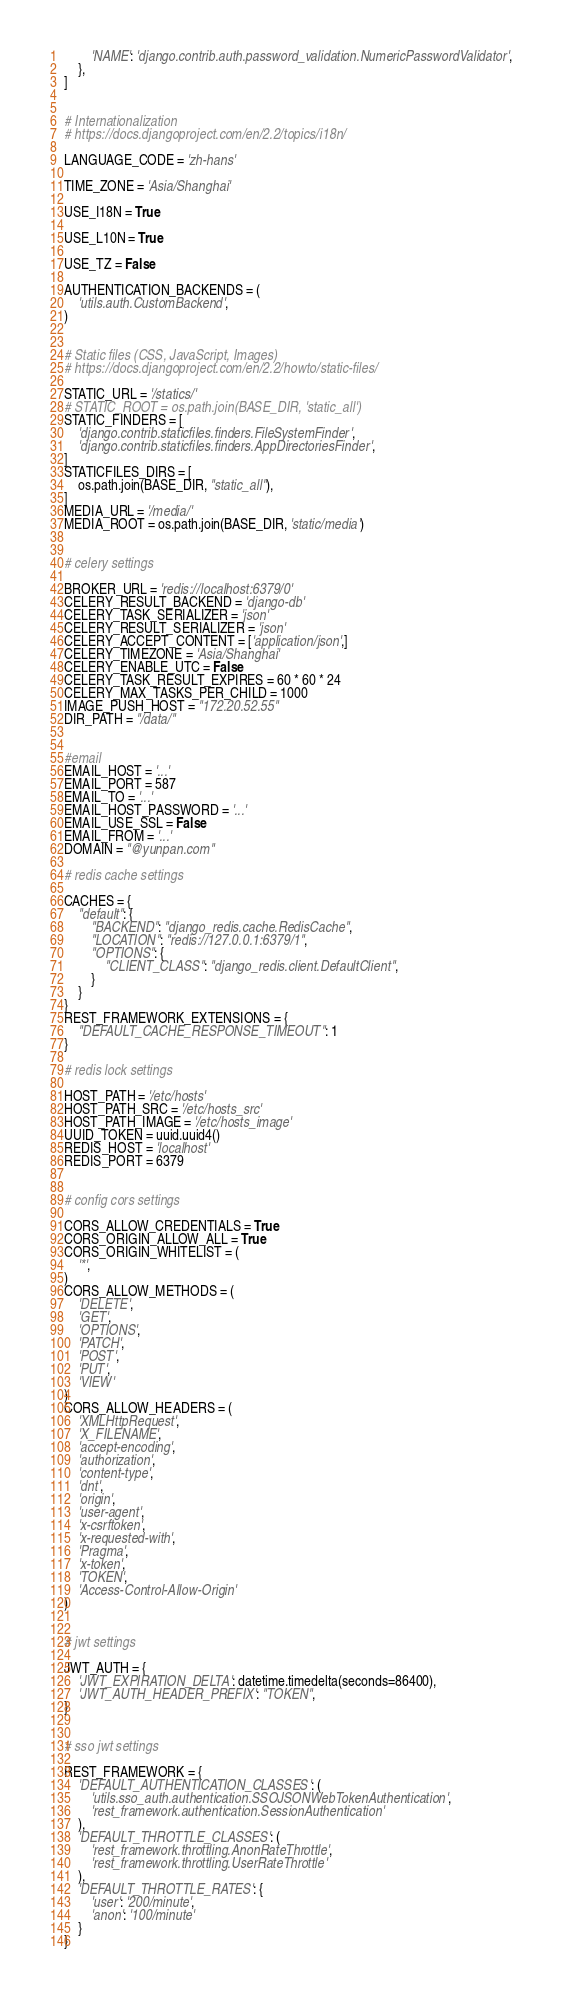<code> <loc_0><loc_0><loc_500><loc_500><_Python_>        'NAME': 'django.contrib.auth.password_validation.NumericPasswordValidator',
    },
]


# Internationalization
# https://docs.djangoproject.com/en/2.2/topics/i18n/

LANGUAGE_CODE = 'zh-hans'

TIME_ZONE = 'Asia/Shanghai'

USE_I18N = True

USE_L10N = True

USE_TZ = False

AUTHENTICATION_BACKENDS = (
    'utils.auth.CustomBackend',
)


# Static files (CSS, JavaScript, Images)
# https://docs.djangoproject.com/en/2.2/howto/static-files/

STATIC_URL = '/statics/'
# STATIC_ROOT = os.path.join(BASE_DIR, 'static_all')
STATIC_FINDERS = [
    'django.contrib.staticfiles.finders.FileSystemFinder',
    'django.contrib.staticfiles.finders.AppDirectoriesFinder',
]
STATICFILES_DIRS = [
    os.path.join(BASE_DIR, "static_all"),
]
MEDIA_URL = '/media/'
MEDIA_ROOT = os.path.join(BASE_DIR, 'static/media')


# celery settings

BROKER_URL = 'redis://localhost:6379/0'
CELERY_RESULT_BACKEND = 'django-db'
CELERY_TASK_SERIALIZER = 'json'
CELERY_RESULT_SERIALIZER = 'json'
CELERY_ACCEPT_CONTENT = ['application/json',]
CELERY_TIMEZONE = 'Asia/Shanghai'
CELERY_ENABLE_UTC = False
CELERY_TASK_RESULT_EXPIRES = 60 * 60 * 24
CELERY_MAX_TASKS_PER_CHILD = 1000
IMAGE_PUSH_HOST = "172.20.52.55"
DIR_PATH = "/data/"


#email
EMAIL_HOST = '...'
EMAIL_PORT = 587
EMAIL_TO = '...'
EMAIL_HOST_PASSWORD = '...'
EMAIL_USE_SSL = False
EMAIL_FROM = '...'
DOMAIN = "@yunpan.com"

# redis cache settings

CACHES = {
    "default": {
        "BACKEND": "django_redis.cache.RedisCache",
        "LOCATION": "redis://127.0.0.1:6379/1",
        "OPTIONS": {
            "CLIENT_CLASS": "django_redis.client.DefaultClient",
        }
    }
}
REST_FRAMEWORK_EXTENSIONS = {
    "DEFAULT_CACHE_RESPONSE_TIMEOUT": 1
}

# redis lock settings

HOST_PATH = '/etc/hosts'
HOST_PATH_SRC = '/etc/hosts_src'
HOST_PATH_IMAGE = '/etc/hosts_image'
UUID_TOKEN = uuid.uuid4()
REDIS_HOST = 'localhost'
REDIS_PORT = 6379


# config cors settings

CORS_ALLOW_CREDENTIALS = True
CORS_ORIGIN_ALLOW_ALL = True
CORS_ORIGIN_WHITELIST = (
    '*',
)
CORS_ALLOW_METHODS = (
    'DELETE',
    'GET',
    'OPTIONS',
    'PATCH',
    'POST',
    'PUT',
    'VIEW'
)
CORS_ALLOW_HEADERS = (
    'XMLHttpRequest',
    'X_FILENAME',
    'accept-encoding',
    'authorization',
    'content-type',
    'dnt',
    'origin',
    'user-agent',
    'x-csrftoken',
    'x-requested-with',
    'Pragma',
    'x-token',
    'TOKEN',
    'Access-Control-Allow-Origin'
)


# jwt settings

JWT_AUTH = {
    'JWT_EXPIRATION_DELTA': datetime.timedelta(seconds=86400),
    'JWT_AUTH_HEADER_PREFIX': "TOKEN",
}


# sso jwt settings

REST_FRAMEWORK = {
    'DEFAULT_AUTHENTICATION_CLASSES': (
        'utils.sso_auth.authentication.SSOJSONWebTokenAuthentication',
        'rest_framework.authentication.SessionAuthentication'
    ),
    'DEFAULT_THROTTLE_CLASSES': (
        'rest_framework.throttling.AnonRateThrottle',
        'rest_framework.throttling.UserRateThrottle'
    ),
    'DEFAULT_THROTTLE_RATES': {
        'user': '200/minute',
        'anon': '100/minute'
    }
}
</code> 